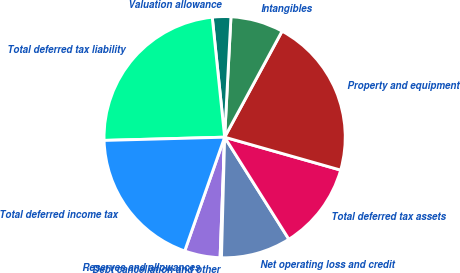Convert chart. <chart><loc_0><loc_0><loc_500><loc_500><pie_chart><fcel>Reserves and allowances<fcel>Debt cancellation and other<fcel>Net operating loss and credit<fcel>Total deferred tax assets<fcel>Property and equipment<fcel>Intangibles<fcel>Valuation allowance<fcel>Total deferred tax liability<fcel>Total deferred income tax<nl><fcel>4.77%<fcel>0.18%<fcel>9.36%<fcel>11.66%<fcel>21.5%<fcel>7.07%<fcel>2.47%<fcel>23.79%<fcel>19.2%<nl></chart> 